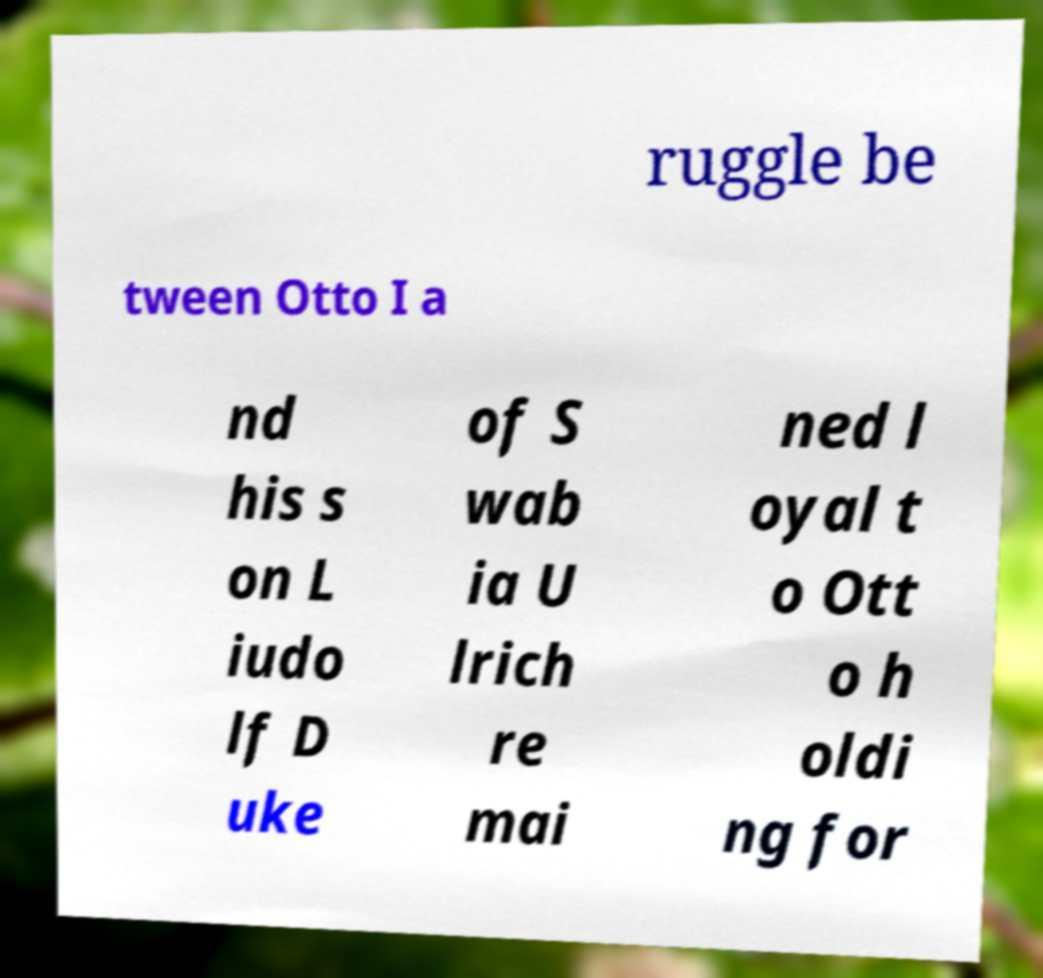Could you assist in decoding the text presented in this image and type it out clearly? ruggle be tween Otto I a nd his s on L iudo lf D uke of S wab ia U lrich re mai ned l oyal t o Ott o h oldi ng for 